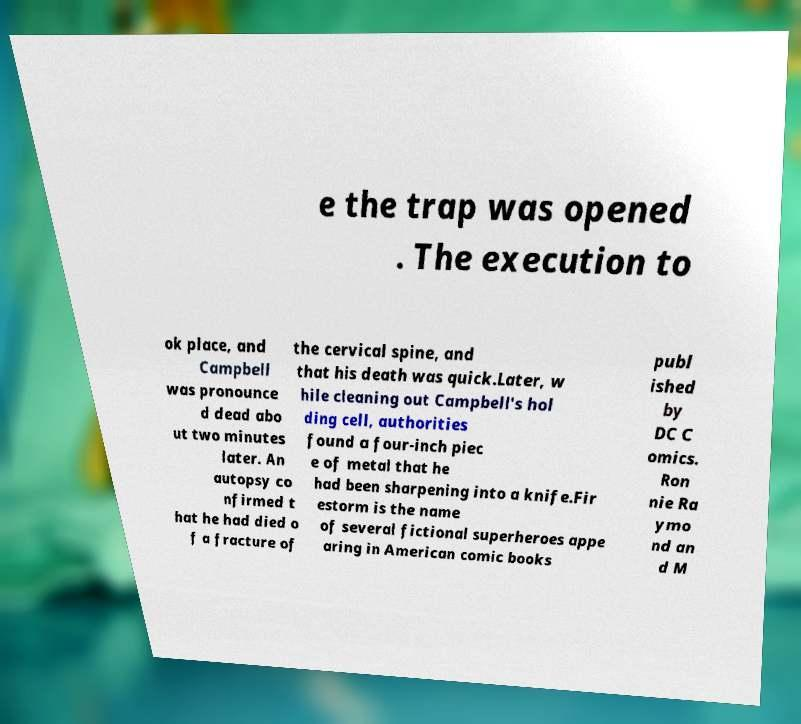I need the written content from this picture converted into text. Can you do that? e the trap was opened . The execution to ok place, and Campbell was pronounce d dead abo ut two minutes later. An autopsy co nfirmed t hat he had died o f a fracture of the cervical spine, and that his death was quick.Later, w hile cleaning out Campbell's hol ding cell, authorities found a four-inch piec e of metal that he had been sharpening into a knife.Fir estorm is the name of several fictional superheroes appe aring in American comic books publ ished by DC C omics. Ron nie Ra ymo nd an d M 